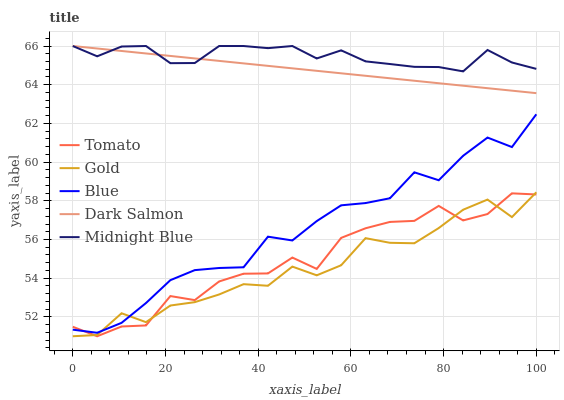Does Blue have the minimum area under the curve?
Answer yes or no. No. Does Blue have the maximum area under the curve?
Answer yes or no. No. Is Blue the smoothest?
Answer yes or no. No. Is Blue the roughest?
Answer yes or no. No. Does Blue have the lowest value?
Answer yes or no. No. Does Blue have the highest value?
Answer yes or no. No. Is Tomato less than Dark Salmon?
Answer yes or no. Yes. Is Midnight Blue greater than Blue?
Answer yes or no. Yes. Does Tomato intersect Dark Salmon?
Answer yes or no. No. 